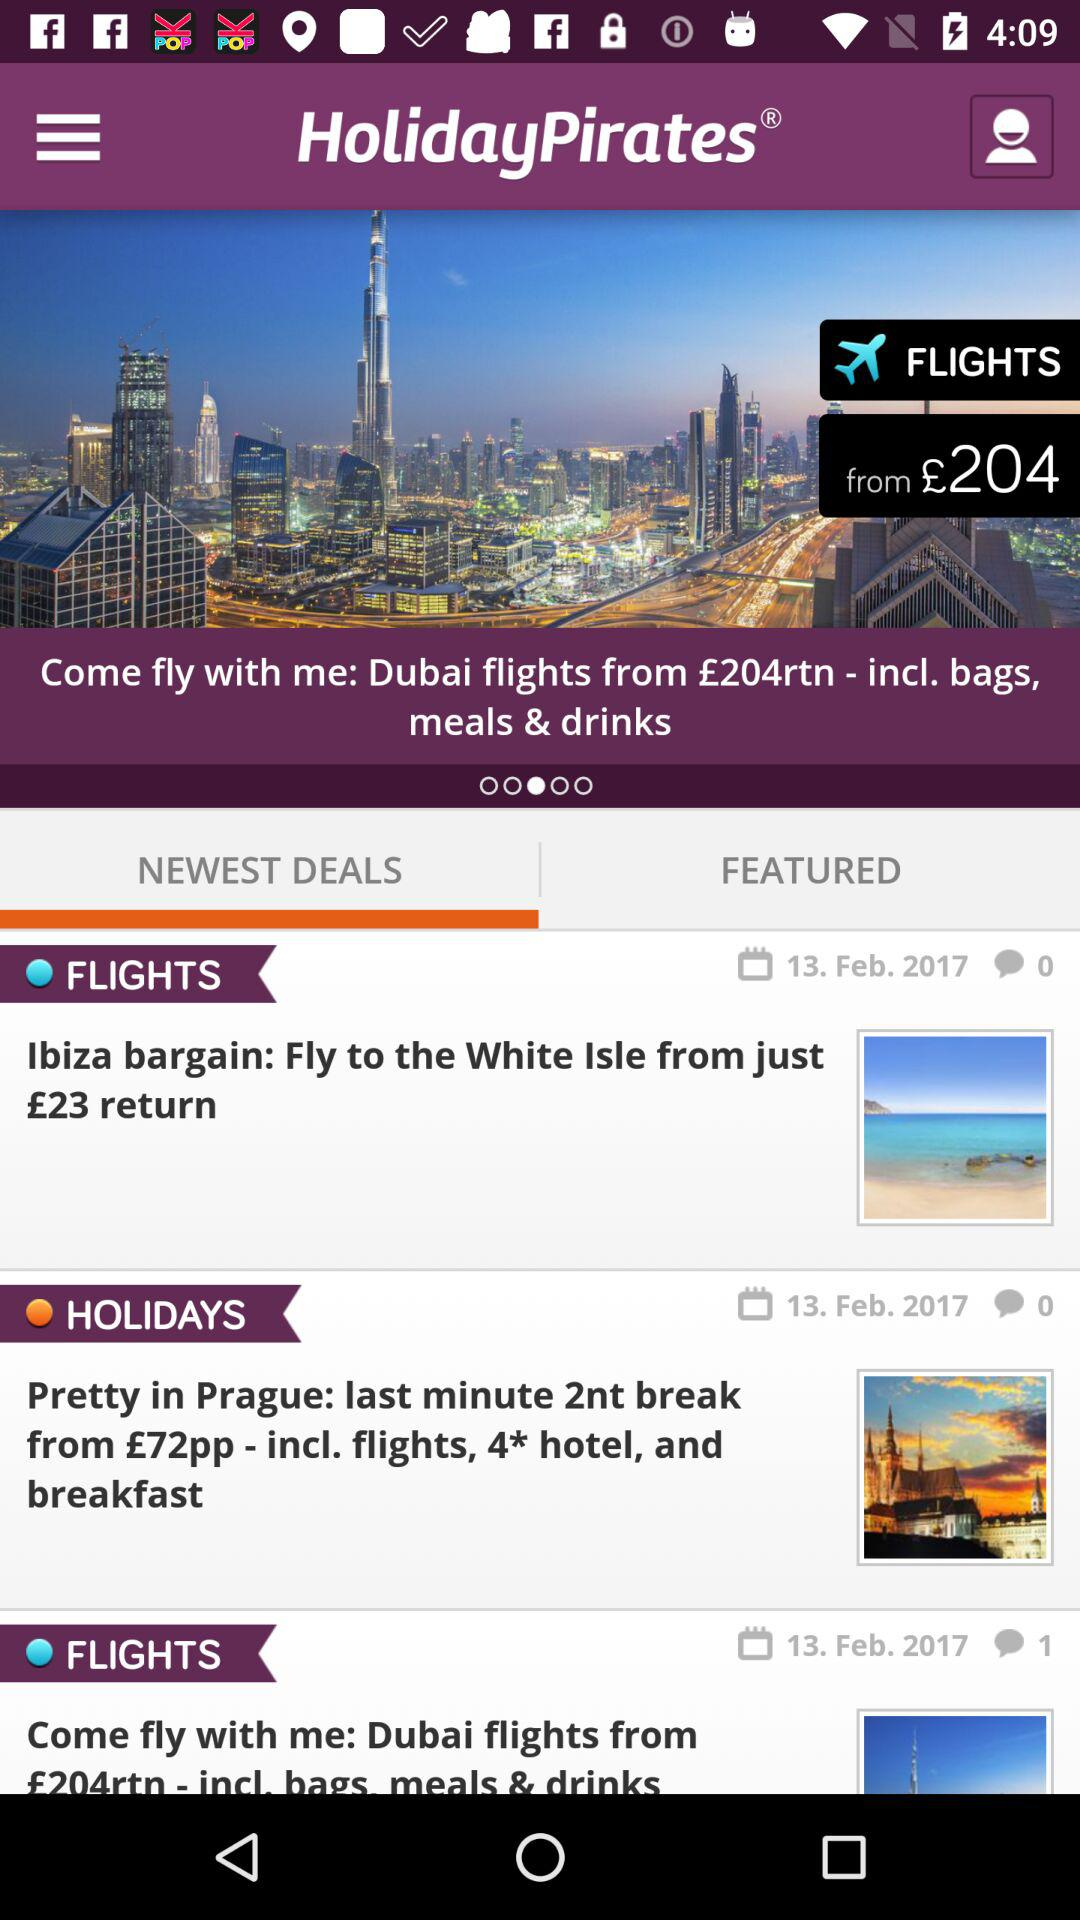What is the name of the application? The name of the application is "HolidayPirates". 